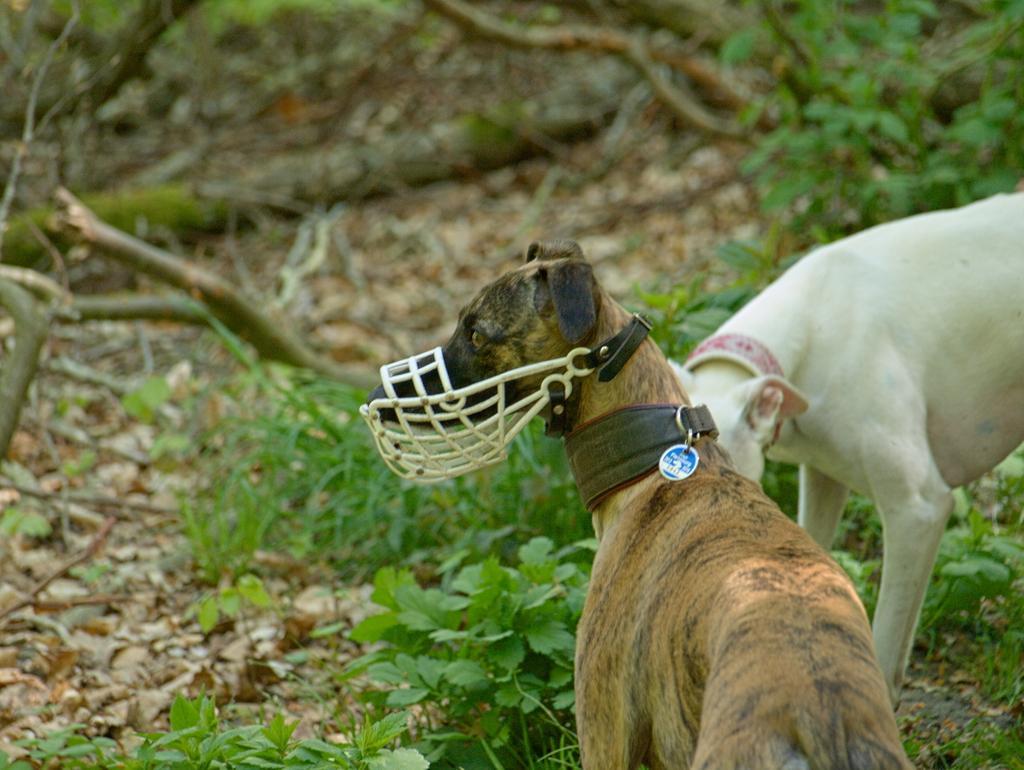Describe this image in one or two sentences. In this image I can see grass ground and on it I can see two dogs are standing. I can also see both the dogs are wearing belts and in the front I can see a white colour mouth cap on the dog's mouth. In the background I can see number of sticks on the ground and I can see colour of these dogs are brown and white. 